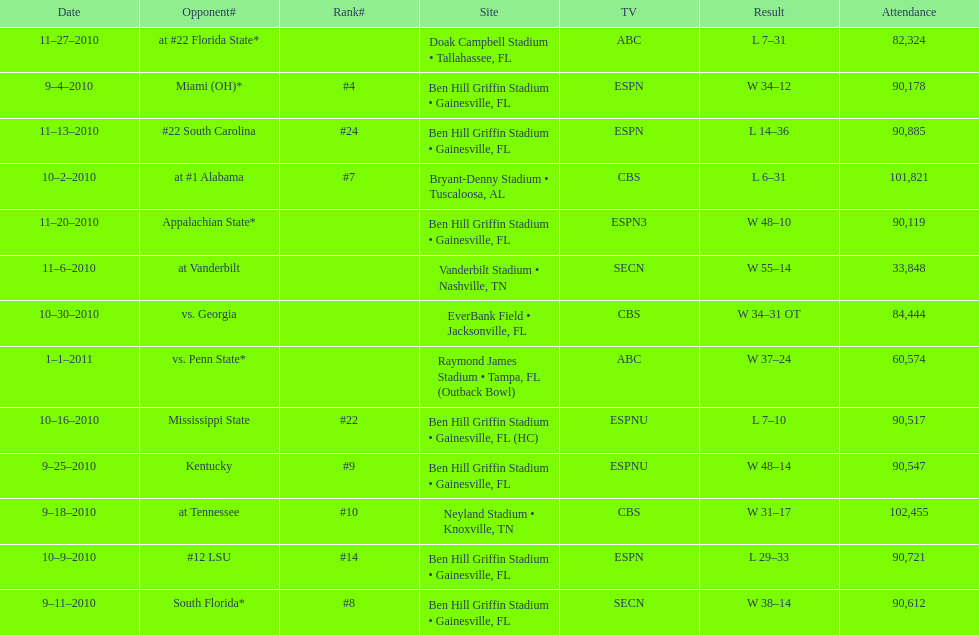What is the number of games played in teh 2010-2011 season 13. 